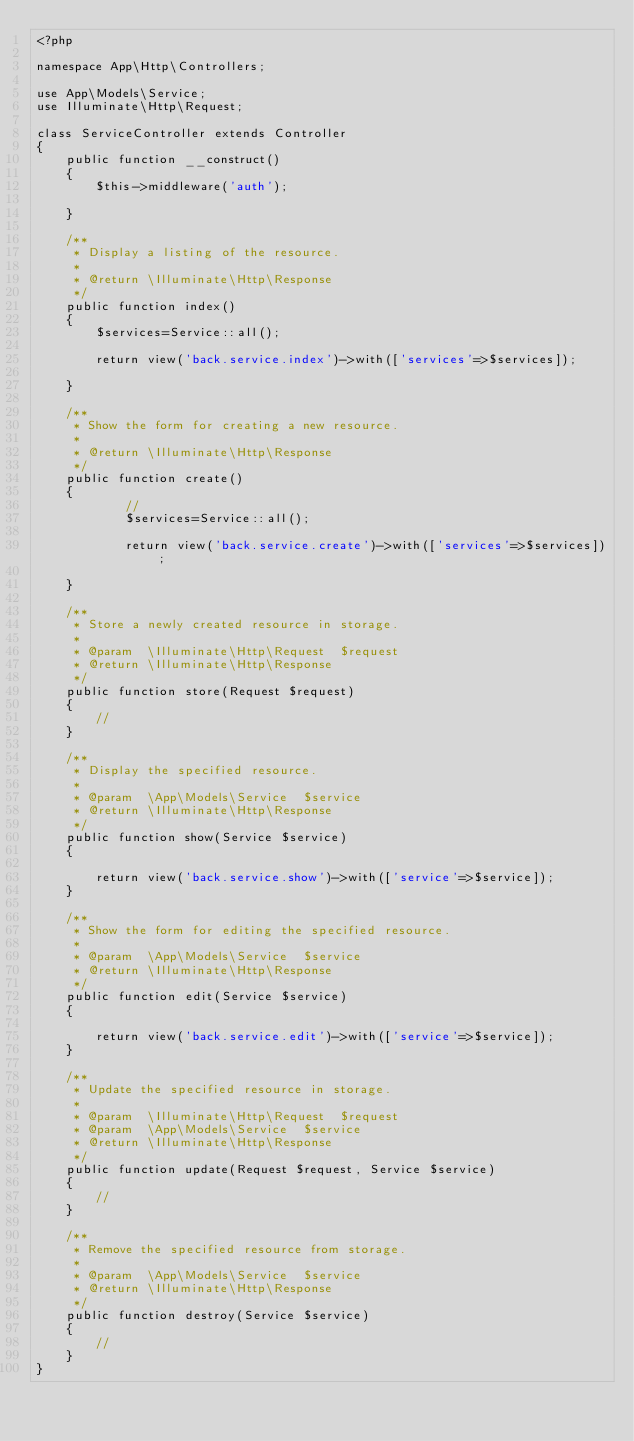<code> <loc_0><loc_0><loc_500><loc_500><_PHP_><?php

namespace App\Http\Controllers;

use App\Models\Service;
use Illuminate\Http\Request;

class ServiceController extends Controller
{
    public function __construct()
    {
        $this->middleware('auth');

    }

    /**
     * Display a listing of the resource.
     *
     * @return \Illuminate\Http\Response
     */
    public function index()
    {
        $services=Service::all();

        return view('back.service.index')->with(['services'=>$services]);

    }

    /**
     * Show the form for creating a new resource.
     *
     * @return \Illuminate\Http\Response
     */
    public function create()
    {
            //
            $services=Service::all();

            return view('back.service.create')->with(['services'=>$services]);

    }

    /**
     * Store a newly created resource in storage.
     *
     * @param  \Illuminate\Http\Request  $request
     * @return \Illuminate\Http\Response
     */
    public function store(Request $request)
    {
        //
    }

    /**
     * Display the specified resource.
     *
     * @param  \App\Models\Service  $service
     * @return \Illuminate\Http\Response
     */
    public function show(Service $service)
    {

        return view('back.service.show')->with(['service'=>$service]);
    }

    /**
     * Show the form for editing the specified resource.
     *
     * @param  \App\Models\Service  $service
     * @return \Illuminate\Http\Response
     */
    public function edit(Service $service)
    {

        return view('back.service.edit')->with(['service'=>$service]);
    }

    /**
     * Update the specified resource in storage.
     *
     * @param  \Illuminate\Http\Request  $request
     * @param  \App\Models\Service  $service
     * @return \Illuminate\Http\Response
     */
    public function update(Request $request, Service $service)
    {
        //
    }

    /**
     * Remove the specified resource from storage.
     *
     * @param  \App\Models\Service  $service
     * @return \Illuminate\Http\Response
     */
    public function destroy(Service $service)
    {
        //
    }
}
</code> 